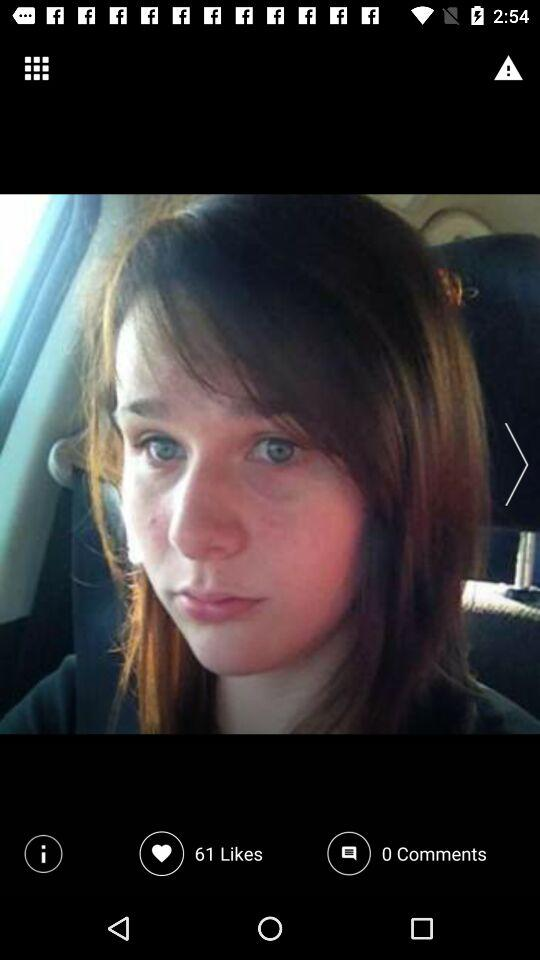How many more likes than comments does the post have?
Answer the question using a single word or phrase. 61 